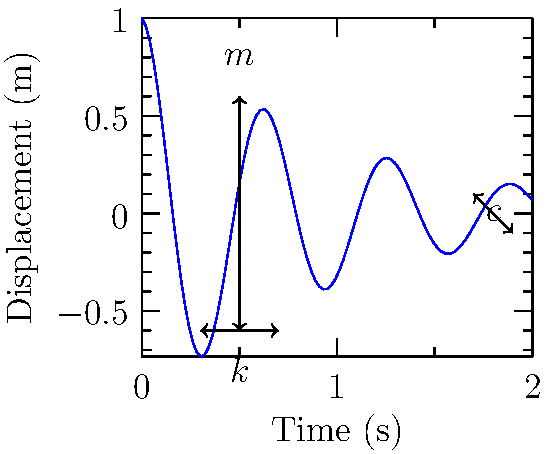In our collaborative project, we're analyzing a spring-mass-damper system with mass $m = 1$ kg, spring constant $k = 100$ N/m, and damping coefficient $c = 2$ Ns/m. The system is initially displaced by 1 meter and released from rest. Calculate the time required for the amplitude to decrease to 10% of its initial value. Let's approach this step-by-step:

1) First, we need to calculate the natural frequency $\omega_n$ and damping ratio $\zeta$:

   $\omega_n = \sqrt{\frac{k}{m}} = \sqrt{\frac{100}{1}} = 10$ rad/s

   $\zeta = \frac{c}{2\sqrt{km}} = \frac{2}{2\sqrt{100 \cdot 1}} = 0.1$

2) The general solution for the displacement of an underdamped system is:

   $x(t) = Ae^{-\zeta\omega_n t} \cos(\omega_d t - \phi)$

   where $\omega_d = \omega_n\sqrt{1-\zeta^2}$ is the damped natural frequency.

3) The amplitude of the oscillation decays according to the exponential term:

   $A(t) = Ae^{-\zeta\omega_n t}$

4) We want to find $t$ when $A(t) = 0.1A$, so:

   $0.1 = e^{-\zeta\omega_n t}$

5) Taking the natural log of both sides:

   $\ln(0.1) = -\zeta\omega_n t$

6) Solving for $t$:

   $t = -\frac{\ln(0.1)}{\zeta\omega_n} = -\frac{\ln(0.1)}{0.1 \cdot 10} = 2.30$ seconds

Therefore, it takes approximately 2.30 seconds for the amplitude to decrease to 10% of its initial value.
Answer: 2.30 seconds 